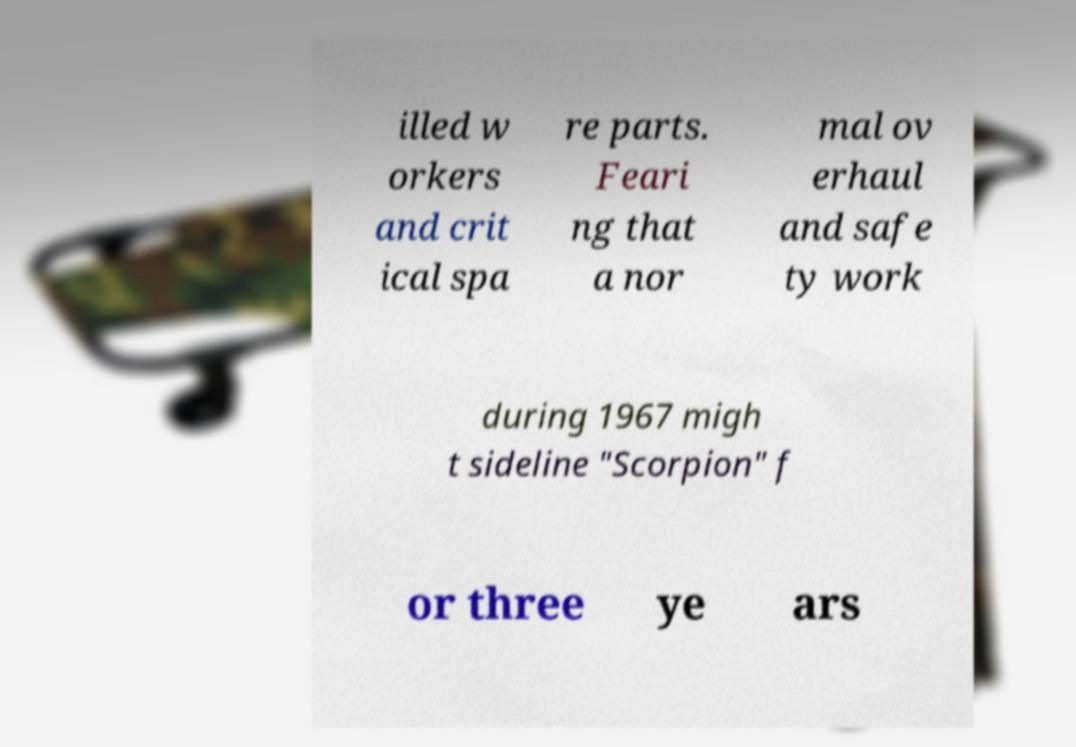For documentation purposes, I need the text within this image transcribed. Could you provide that? illed w orkers and crit ical spa re parts. Feari ng that a nor mal ov erhaul and safe ty work during 1967 migh t sideline "Scorpion" f or three ye ars 